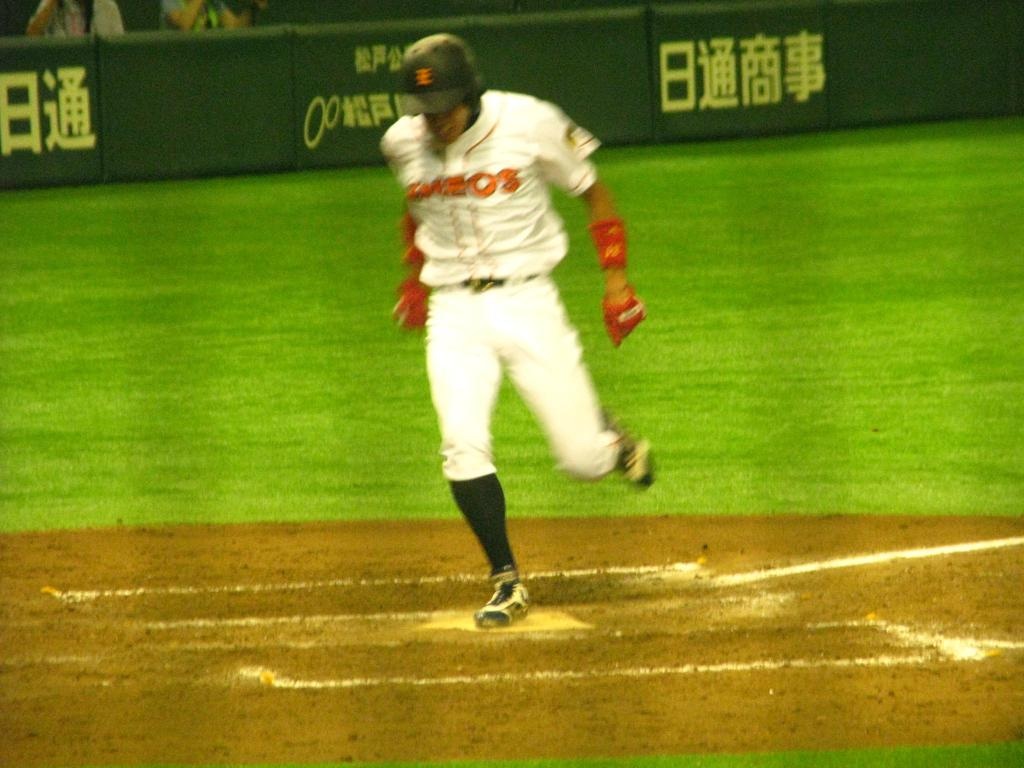Provide a one-sentence caption for the provided image. A baseball player gets to a base, the barrier to the stands covered in Asian letters. 